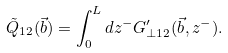<formula> <loc_0><loc_0><loc_500><loc_500>\tilde { Q } _ { 1 2 } ( \vec { b } ) = \int ^ { L } _ { 0 } d z ^ { - } G ^ { \prime } _ { \bot 1 2 } ( { \vec { b } } , z ^ { - } ) .</formula> 